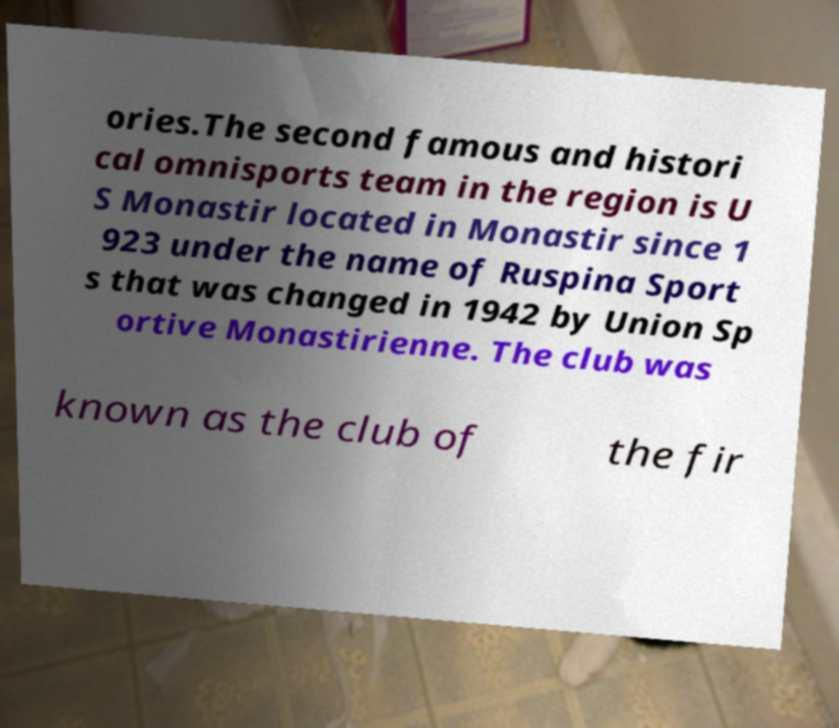Please identify and transcribe the text found in this image. ories.The second famous and histori cal omnisports team in the region is U S Monastir located in Monastir since 1 923 under the name of Ruspina Sport s that was changed in 1942 by Union Sp ortive Monastirienne. The club was known as the club of the fir 